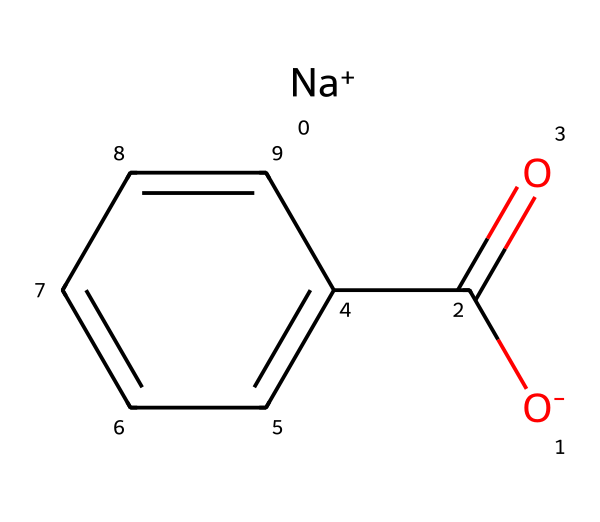What is the total number of carbon atoms in sodium benzoate? In the provided SMILES representation, we can identify two parts. The "c1ccccc1" indicates a benzene ring, which has 6 carbon atoms. In addition, there is one carbon atom in the carboxylate group "C(=O)". Therefore, the total number of carbon atoms is 6 + 1 = 7.
Answer: 7 What type of chemical bond exists between the carbon and oxygen in the carboxylate group? The carboxylate group "C(=O)" contains a double bond between the carbon and oxygen. The "=" symbol in the SMILES indicates that this bond is a double bond.
Answer: double bond How many oxygen atoms are present in sodium benzoate? The chemical structure consists of one oxygen atom in the carboxylate group (C=O) and another in the ionized form ([O-]). Thus, there are a total of two oxygen atoms.
Answer: 2 What is the ionic component of sodium benzoate? The "[Na+]" part of the SMILES indicates the sodium ion is positively charged, making it the ionic component of the molecule.
Answer: sodium ion What functional group is present in sodium benzoate? The carboxylate group "C(=O)O" is present in the structure, which characterizes it as a carboxylate. This group is key to its functions as a preservative.
Answer: carboxylate How does sodium benzoate act as a preservative in food? Sodium benzoate prevents the growth of bacteria, yeast, and molds in acidic conditions, which allows it to preserve food products, especially soft drinks.
Answer: prevents microbial growth 